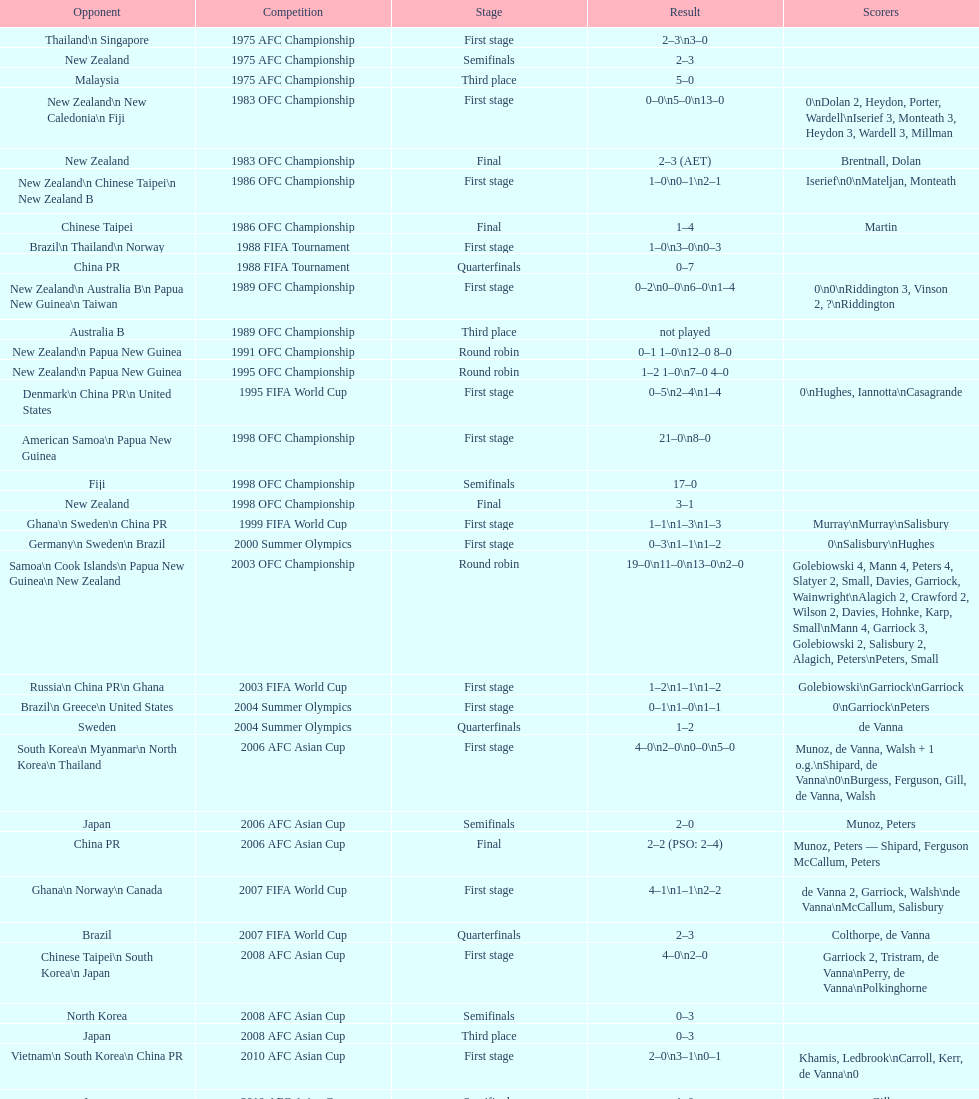Help me parse the entirety of this table. {'header': ['Opponent', 'Competition', 'Stage', 'Result', 'Scorers'], 'rows': [['Thailand\\n\xa0Singapore', '1975 AFC Championship', 'First stage', '2–3\\n3–0', ''], ['New Zealand', '1975 AFC Championship', 'Semifinals', '2–3', ''], ['Malaysia', '1975 AFC Championship', 'Third place', '5–0', ''], ['New Zealand\\n\xa0New Caledonia\\n\xa0Fiji', '1983 OFC Championship', 'First stage', '0–0\\n5–0\\n13–0', '0\\nDolan 2, Heydon, Porter, Wardell\\nIserief 3, Monteath 3, Heydon 3, Wardell 3, Millman'], ['New Zealand', '1983 OFC Championship', 'Final', '2–3 (AET)', 'Brentnall, Dolan'], ['New Zealand\\n\xa0Chinese Taipei\\n New Zealand B', '1986 OFC Championship', 'First stage', '1–0\\n0–1\\n2–1', 'Iserief\\n0\\nMateljan, Monteath'], ['Chinese Taipei', '1986 OFC Championship', 'Final', '1–4', 'Martin'], ['Brazil\\n\xa0Thailand\\n\xa0Norway', '1988 FIFA Tournament', 'First stage', '1–0\\n3–0\\n0–3', ''], ['China PR', '1988 FIFA Tournament', 'Quarterfinals', '0–7', ''], ['New Zealand\\n Australia B\\n\xa0Papua New Guinea\\n\xa0Taiwan', '1989 OFC Championship', 'First stage', '0–2\\n0–0\\n6–0\\n1–4', '0\\n0\\nRiddington 3, Vinson 2,\xa0?\\nRiddington'], ['Australia B', '1989 OFC Championship', 'Third place', 'not played', ''], ['New Zealand\\n\xa0Papua New Guinea', '1991 OFC Championship', 'Round robin', '0–1 1–0\\n12–0 8–0', ''], ['New Zealand\\n\xa0Papua New Guinea', '1995 OFC Championship', 'Round robin', '1–2 1–0\\n7–0 4–0', ''], ['Denmark\\n\xa0China PR\\n\xa0United States', '1995 FIFA World Cup', 'First stage', '0–5\\n2–4\\n1–4', '0\\nHughes, Iannotta\\nCasagrande'], ['American Samoa\\n\xa0Papua New Guinea', '1998 OFC Championship', 'First stage', '21–0\\n8–0', ''], ['Fiji', '1998 OFC Championship', 'Semifinals', '17–0', ''], ['New Zealand', '1998 OFC Championship', 'Final', '3–1', ''], ['Ghana\\n\xa0Sweden\\n\xa0China PR', '1999 FIFA World Cup', 'First stage', '1–1\\n1–3\\n1–3', 'Murray\\nMurray\\nSalisbury'], ['Germany\\n\xa0Sweden\\n\xa0Brazil', '2000 Summer Olympics', 'First stage', '0–3\\n1–1\\n1–2', '0\\nSalisbury\\nHughes'], ['Samoa\\n\xa0Cook Islands\\n\xa0Papua New Guinea\\n\xa0New Zealand', '2003 OFC Championship', 'Round robin', '19–0\\n11–0\\n13–0\\n2–0', 'Golebiowski 4, Mann 4, Peters 4, Slatyer 2, Small, Davies, Garriock, Wainwright\\nAlagich 2, Crawford 2, Wilson 2, Davies, Hohnke, Karp, Small\\nMann 4, Garriock 3, Golebiowski 2, Salisbury 2, Alagich, Peters\\nPeters, Small'], ['Russia\\n\xa0China PR\\n\xa0Ghana', '2003 FIFA World Cup', 'First stage', '1–2\\n1–1\\n1–2', 'Golebiowski\\nGarriock\\nGarriock'], ['Brazil\\n\xa0Greece\\n\xa0United States', '2004 Summer Olympics', 'First stage', '0–1\\n1–0\\n1–1', '0\\nGarriock\\nPeters'], ['Sweden', '2004 Summer Olympics', 'Quarterfinals', '1–2', 'de Vanna'], ['South Korea\\n\xa0Myanmar\\n\xa0North Korea\\n\xa0Thailand', '2006 AFC Asian Cup', 'First stage', '4–0\\n2–0\\n0–0\\n5–0', 'Munoz, de Vanna, Walsh + 1 o.g.\\nShipard, de Vanna\\n0\\nBurgess, Ferguson, Gill, de Vanna, Walsh'], ['Japan', '2006 AFC Asian Cup', 'Semifinals', '2–0', 'Munoz, Peters'], ['China PR', '2006 AFC Asian Cup', 'Final', '2–2 (PSO: 2–4)', 'Munoz, Peters — Shipard, Ferguson McCallum, Peters'], ['Ghana\\n\xa0Norway\\n\xa0Canada', '2007 FIFA World Cup', 'First stage', '4–1\\n1–1\\n2–2', 'de Vanna 2, Garriock, Walsh\\nde Vanna\\nMcCallum, Salisbury'], ['Brazil', '2007 FIFA World Cup', 'Quarterfinals', '2–3', 'Colthorpe, de Vanna'], ['Chinese Taipei\\n\xa0South Korea\\n\xa0Japan', '2008 AFC Asian Cup', 'First stage', '4–0\\n2–0', 'Garriock 2, Tristram, de Vanna\\nPerry, de Vanna\\nPolkinghorne'], ['North Korea', '2008 AFC Asian Cup', 'Semifinals', '0–3', ''], ['Japan', '2008 AFC Asian Cup', 'Third place', '0–3', ''], ['Vietnam\\n\xa0South Korea\\n\xa0China PR', '2010 AFC Asian Cup', 'First stage', '2–0\\n3–1\\n0–1', 'Khamis, Ledbrook\\nCarroll, Kerr, de Vanna\\n0'], ['Japan', '2010 AFC Asian Cup', 'Semifinals', '1–0', 'Gill'], ['North Korea', '2010 AFC Asian Cup', 'Final', '1–1 (PSO: 5–4)', 'Kerr — PSO: Shipard, Ledbrook, Gill, Garriock, Simon'], ['Brazil\\n\xa0Equatorial Guinea\\n\xa0Norway', '2011 FIFA World Cup', 'First stage', '0–1\\n3–2\\n2–1', '0\\nvan Egmond, Khamis, de Vanna\\nSimon 2'], ['Sweden', '2011 FIFA World Cup', 'Quarterfinals', '1–3', 'Perry'], ['North Korea\\n\xa0Thailand\\n\xa0Japan\\n\xa0China PR\\n\xa0South Korea', '2012 Summer Olympics\\nAFC qualification', 'Final round', '0–1\\n5–1\\n0–1\\n1–0\\n2–1', '0\\nHeyman 2, Butt, van Egmond, Simon\\n0\\nvan Egmond\\nButt, de Vanna'], ['Japan\\n\xa0Jordan\\n\xa0Vietnam', '2014 AFC Asian Cup', 'First stage', 'TBD\\nTBD\\nTBD', '']]} What it the total number of countries in the first stage of the 2008 afc asian cup? 4. 